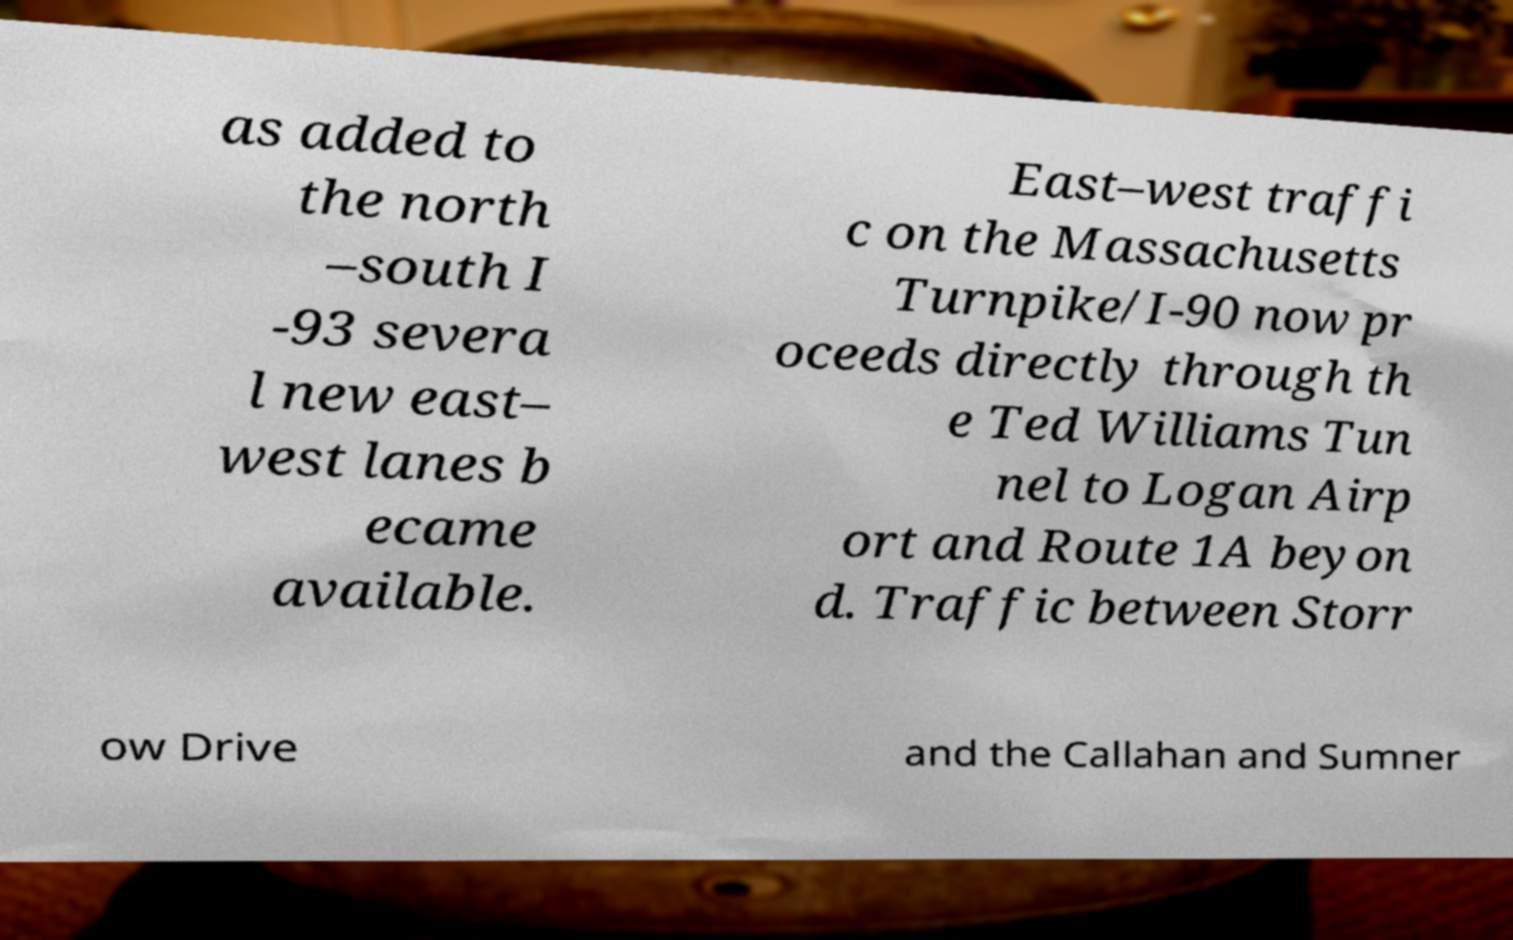Please read and relay the text visible in this image. What does it say? as added to the north –south I -93 severa l new east– west lanes b ecame available. East–west traffi c on the Massachusetts Turnpike/I-90 now pr oceeds directly through th e Ted Williams Tun nel to Logan Airp ort and Route 1A beyon d. Traffic between Storr ow Drive and the Callahan and Sumner 